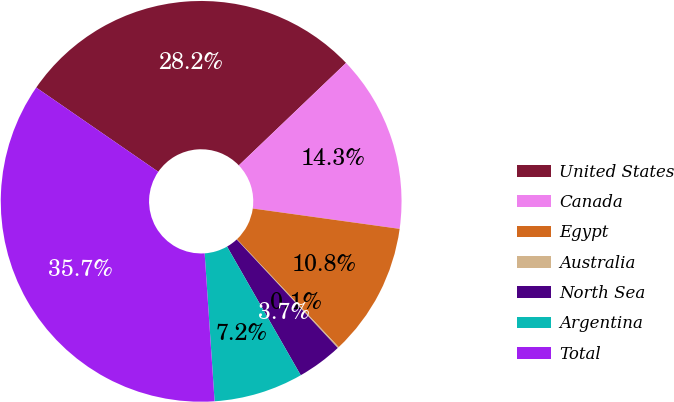Convert chart. <chart><loc_0><loc_0><loc_500><loc_500><pie_chart><fcel>United States<fcel>Canada<fcel>Egypt<fcel>Australia<fcel>North Sea<fcel>Argentina<fcel>Total<nl><fcel>28.25%<fcel>14.33%<fcel>10.77%<fcel>0.1%<fcel>3.66%<fcel>7.21%<fcel>35.68%<nl></chart> 